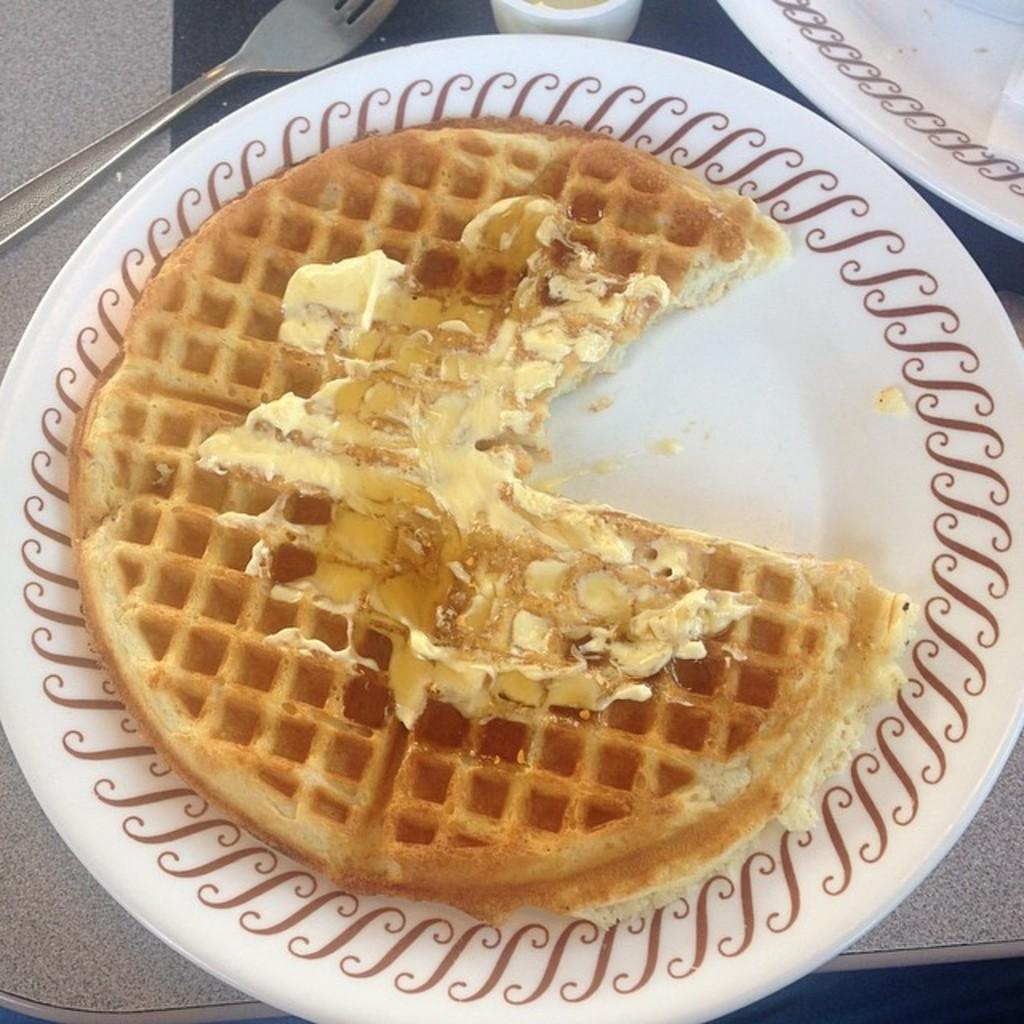What is the main food item visible on a plate in the image? There is a waffle on a plate in the image. Are there any other plates visible in the image? Yes, there is another plate in the image. What utensil is present in the image? There is a fork in the image. Where are all the mentioned objects placed? All the mentioned objects are placed on a table. What date is circled on the calendar in the image? There is no calendar present in the image. How does the waffle feel about the fork in the image? The waffle is an inanimate object and does not have feelings, so it cannot feel anything about the fork. 